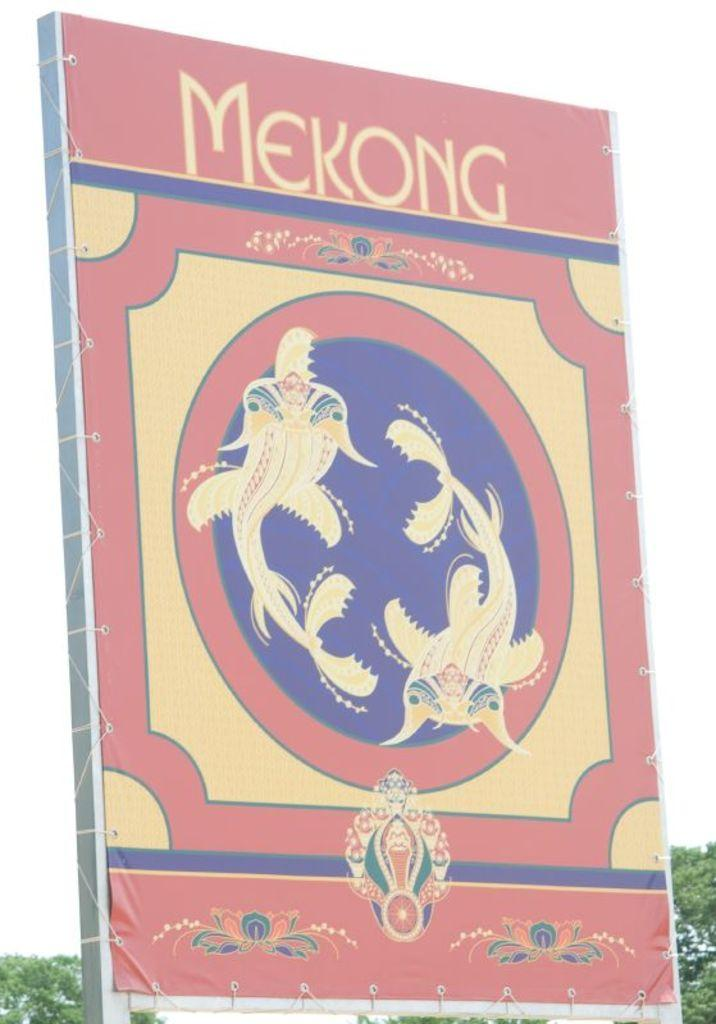<image>
Share a concise interpretation of the image provided. A large pastel poster for Mekong with 2 koi fish in a circle. 